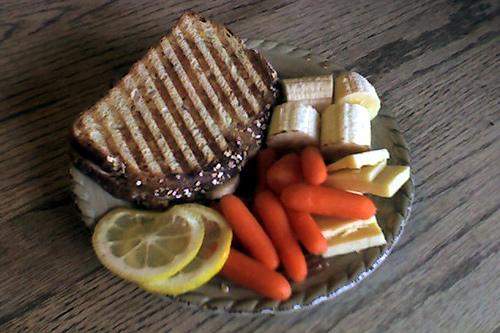What is the orange veggie?
Write a very short answer. Carrots. What are the two fruits on this plate?
Concise answer only. Banana lemon. Is the bread grilled?
Keep it brief. Yes. 